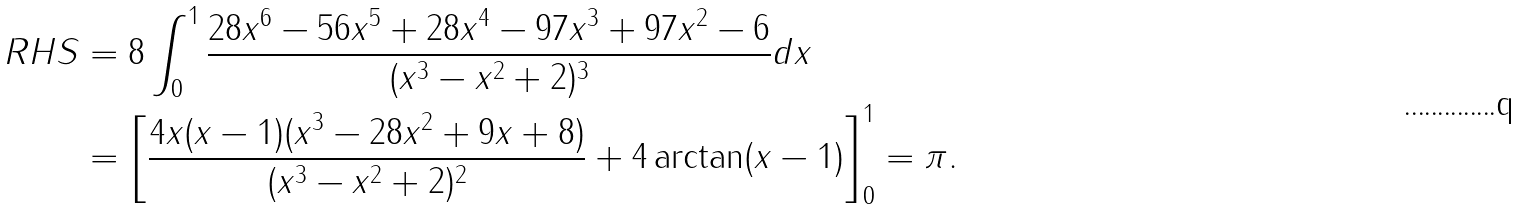<formula> <loc_0><loc_0><loc_500><loc_500>R H S & = 8 \int _ { 0 } ^ { 1 } \frac { 2 8 x ^ { 6 } - 5 6 x ^ { 5 } + 2 8 x ^ { 4 } - 9 7 x ^ { 3 } + 9 7 x ^ { 2 } - 6 } { ( x ^ { 3 } - x ^ { 2 } + 2 ) ^ { 3 } } d x \\ & = \left [ \frac { 4 x ( x - 1 ) ( x ^ { 3 } - 2 8 x ^ { 2 } + 9 x + 8 ) } { ( x ^ { 3 } - x ^ { 2 } + 2 ) ^ { 2 } } + 4 \arctan ( x - 1 ) \right ] _ { 0 } ^ { 1 } = \pi .</formula> 